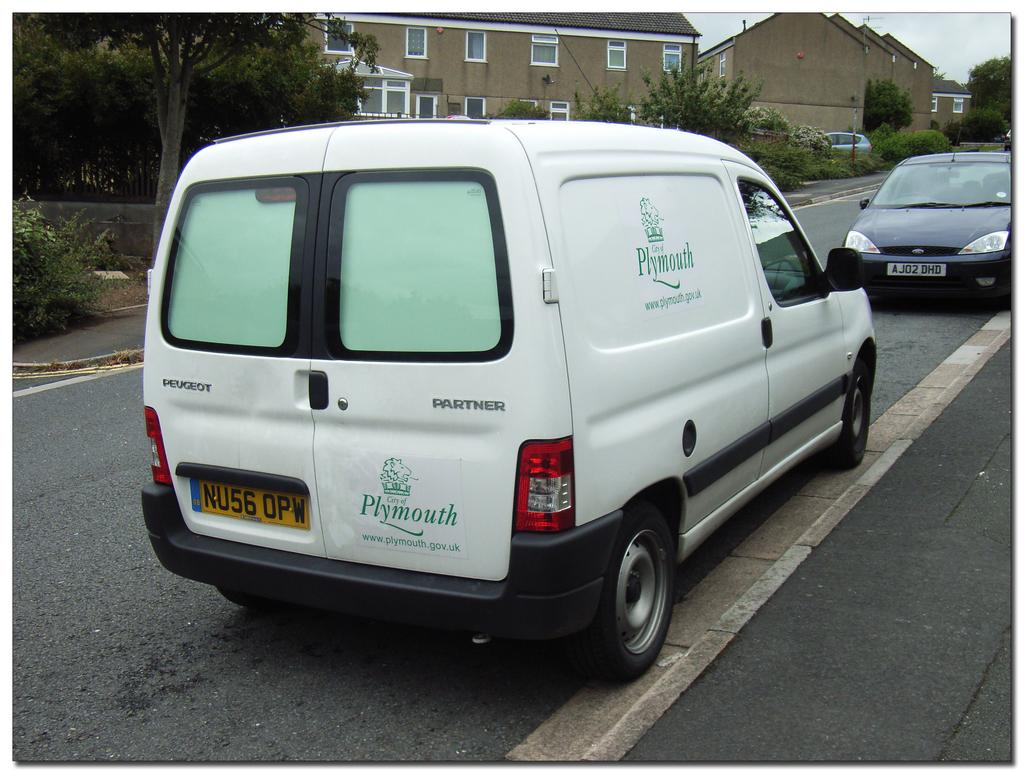<image>
Present a compact description of the photo's key features. A white panel van that says Plymouth was actually built by Peugot. 